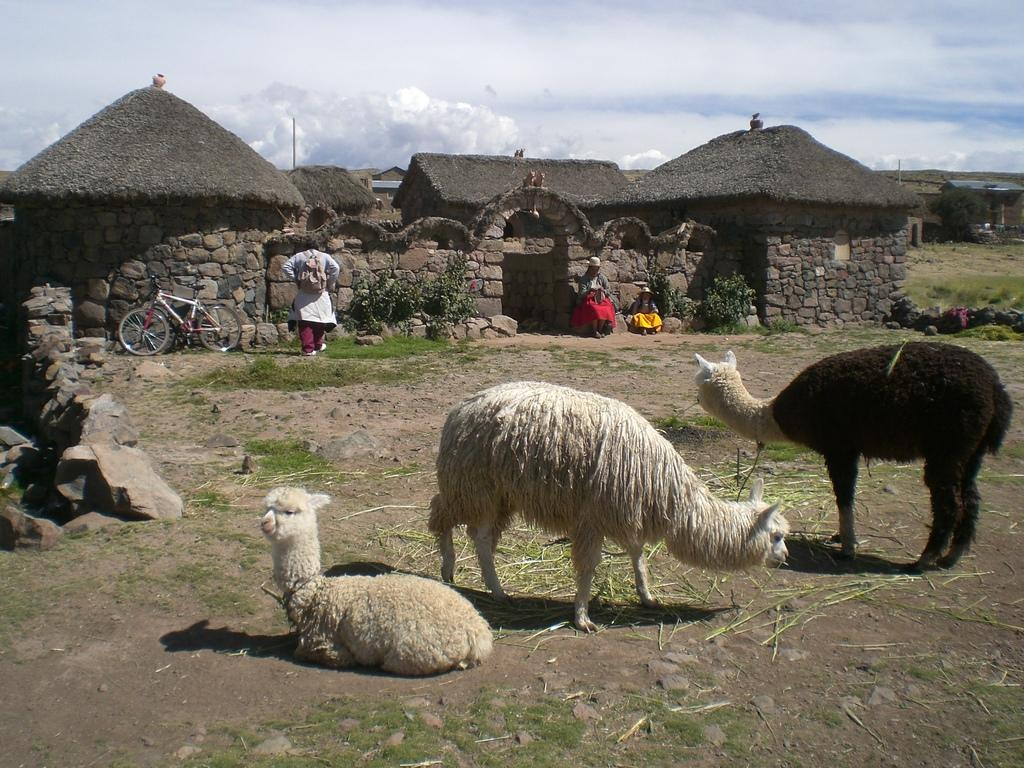What can be seen on the ground in the image? There are animals on the ground in the image. What is visible in the background of the image? In the background, there are people, houses, walls, a bicycle, plants, various objects, grass, and the sky. Can you describe the sky in the image? The sky is visible in the background of the image, and it appears to be cloudy. What type of pollution can be seen in the image? There is no pollution visible in the image. What kind of marble is present in the image? There is no marble present in the image. 